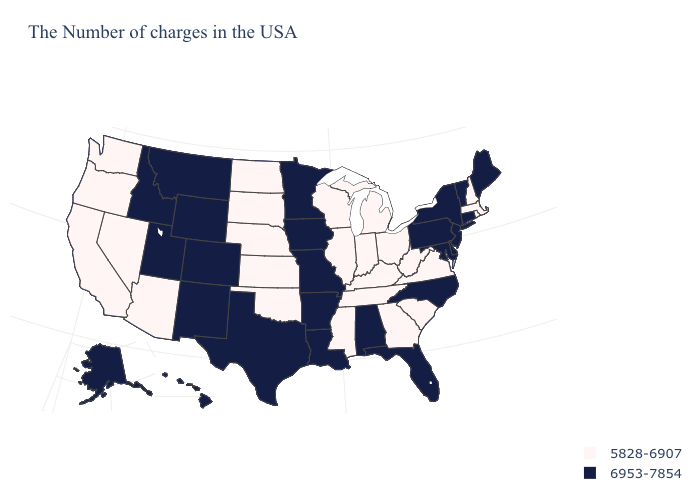Name the states that have a value in the range 5828-6907?
Answer briefly. Massachusetts, Rhode Island, New Hampshire, Virginia, South Carolina, West Virginia, Ohio, Georgia, Michigan, Kentucky, Indiana, Tennessee, Wisconsin, Illinois, Mississippi, Kansas, Nebraska, Oklahoma, South Dakota, North Dakota, Arizona, Nevada, California, Washington, Oregon. Which states have the lowest value in the MidWest?
Quick response, please. Ohio, Michigan, Indiana, Wisconsin, Illinois, Kansas, Nebraska, South Dakota, North Dakota. Among the states that border Washington , which have the lowest value?
Write a very short answer. Oregon. Does New Jersey have the lowest value in the Northeast?
Short answer required. No. What is the value of New Jersey?
Give a very brief answer. 6953-7854. Name the states that have a value in the range 5828-6907?
Short answer required. Massachusetts, Rhode Island, New Hampshire, Virginia, South Carolina, West Virginia, Ohio, Georgia, Michigan, Kentucky, Indiana, Tennessee, Wisconsin, Illinois, Mississippi, Kansas, Nebraska, Oklahoma, South Dakota, North Dakota, Arizona, Nevada, California, Washington, Oregon. Which states have the highest value in the USA?
Be succinct. Maine, Vermont, Connecticut, New York, New Jersey, Delaware, Maryland, Pennsylvania, North Carolina, Florida, Alabama, Louisiana, Missouri, Arkansas, Minnesota, Iowa, Texas, Wyoming, Colorado, New Mexico, Utah, Montana, Idaho, Alaska, Hawaii. What is the lowest value in states that border Pennsylvania?
Give a very brief answer. 5828-6907. What is the value of South Dakota?
Write a very short answer. 5828-6907. What is the highest value in the USA?
Short answer required. 6953-7854. What is the value of Michigan?
Answer briefly. 5828-6907. What is the value of Texas?
Give a very brief answer. 6953-7854. Name the states that have a value in the range 5828-6907?
Concise answer only. Massachusetts, Rhode Island, New Hampshire, Virginia, South Carolina, West Virginia, Ohio, Georgia, Michigan, Kentucky, Indiana, Tennessee, Wisconsin, Illinois, Mississippi, Kansas, Nebraska, Oklahoma, South Dakota, North Dakota, Arizona, Nevada, California, Washington, Oregon. Is the legend a continuous bar?
Give a very brief answer. No. Name the states that have a value in the range 5828-6907?
Short answer required. Massachusetts, Rhode Island, New Hampshire, Virginia, South Carolina, West Virginia, Ohio, Georgia, Michigan, Kentucky, Indiana, Tennessee, Wisconsin, Illinois, Mississippi, Kansas, Nebraska, Oklahoma, South Dakota, North Dakota, Arizona, Nevada, California, Washington, Oregon. 